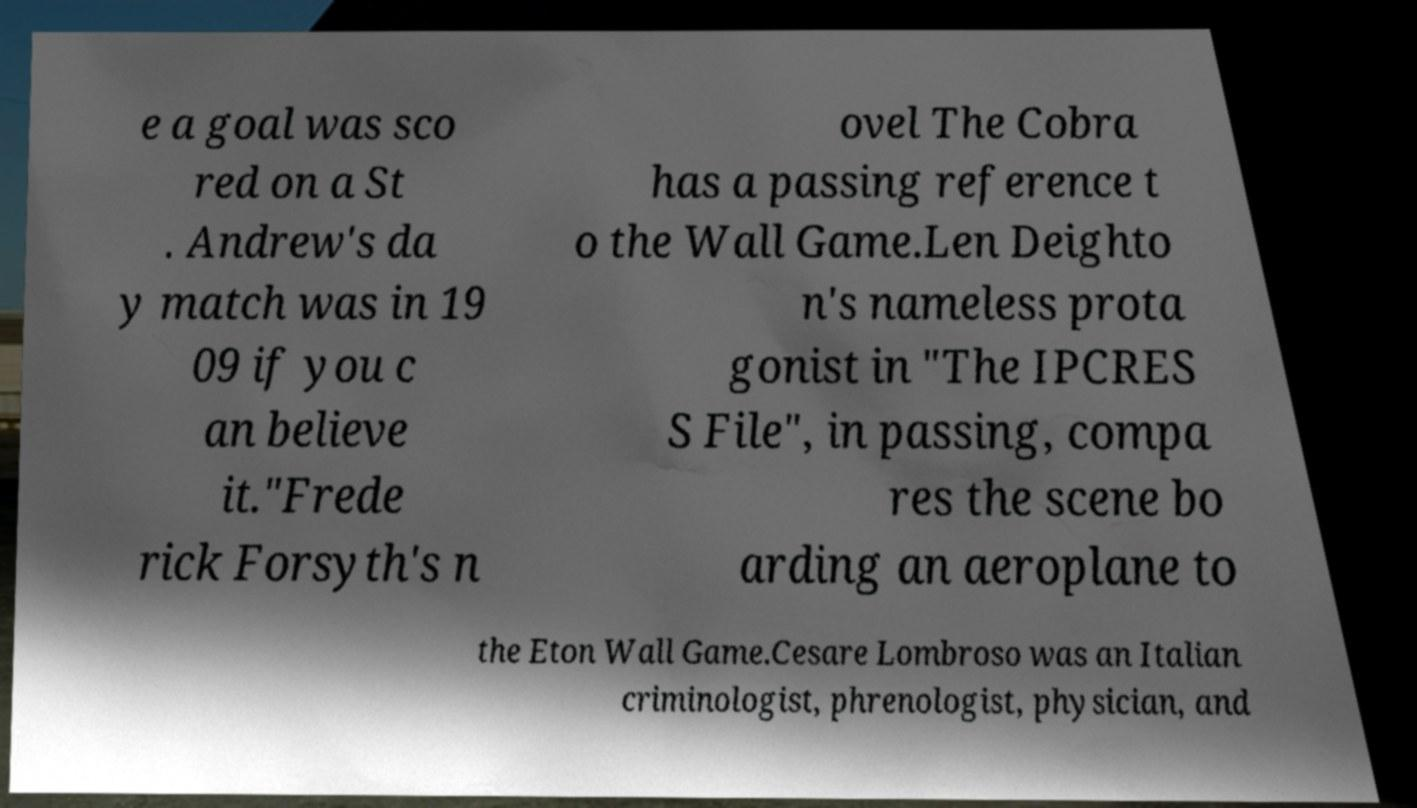Could you extract and type out the text from this image? e a goal was sco red on a St . Andrew's da y match was in 19 09 if you c an believe it."Frede rick Forsyth's n ovel The Cobra has a passing reference t o the Wall Game.Len Deighto n's nameless prota gonist in "The IPCRES S File", in passing, compa res the scene bo arding an aeroplane to the Eton Wall Game.Cesare Lombroso was an Italian criminologist, phrenologist, physician, and 